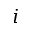Convert formula to latex. <formula><loc_0><loc_0><loc_500><loc_500>i</formula> 